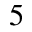Convert formula to latex. <formula><loc_0><loc_0><loc_500><loc_500>5</formula> 